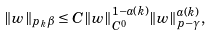Convert formula to latex. <formula><loc_0><loc_0><loc_500><loc_500>\| w \| _ { p _ { k } \beta } \leq C \| w \| _ { C ^ { 0 } } ^ { 1 - a ( k ) } \| w \| _ { p - \gamma } ^ { a ( k ) } ,</formula> 